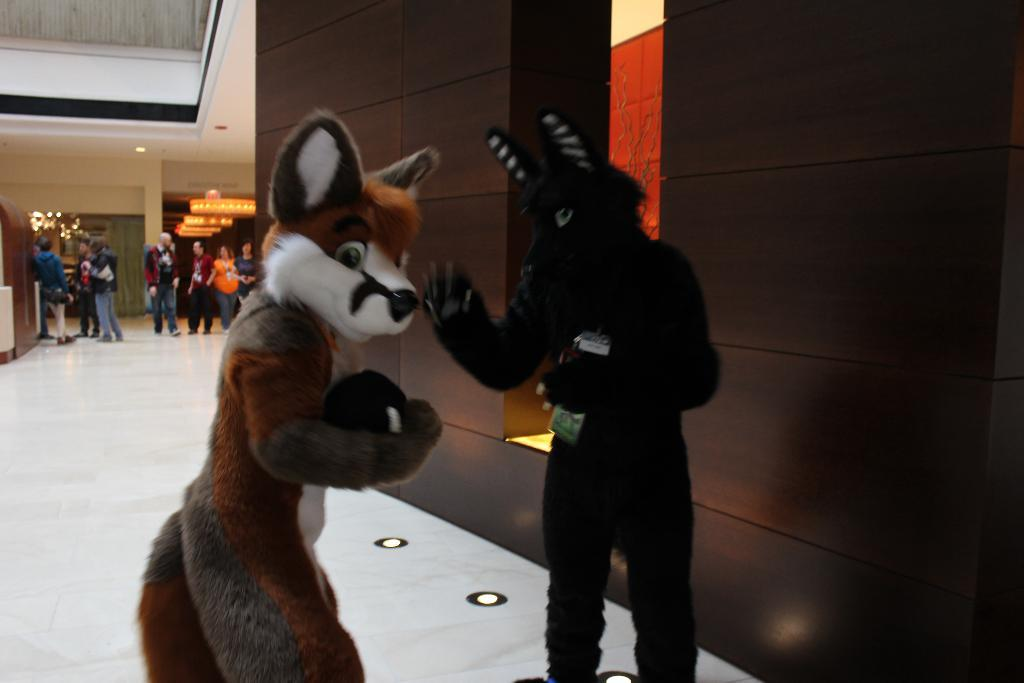Who or what can be seen in the image? There are people in the image. What else is present in the image besides people? There are toys in the image. Can you describe the ground in the image? The ground is visible in the image, and it has lights on it. What is the appearance of the wall in the image? The wall in the image has lights on it. Are there any objects attached to the wall or roof? Yes, there are objects attached to the wall or roof. What type of pollution can be seen in the image? There is no pollution visible in the image. Is there a basketball game taking place in the image? There is no basketball game or any reference to basketball in the image. 